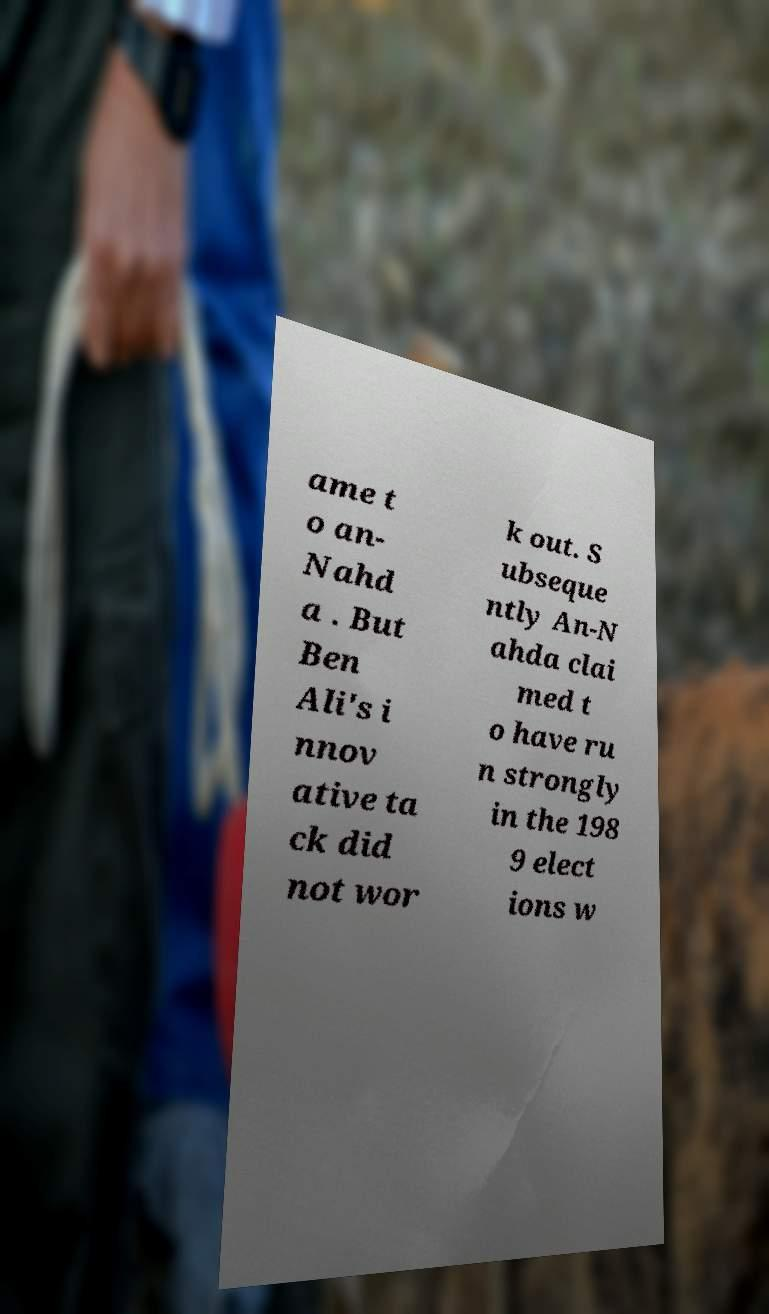There's text embedded in this image that I need extracted. Can you transcribe it verbatim? ame t o an- Nahd a . But Ben Ali's i nnov ative ta ck did not wor k out. S ubseque ntly An-N ahda clai med t o have ru n strongly in the 198 9 elect ions w 